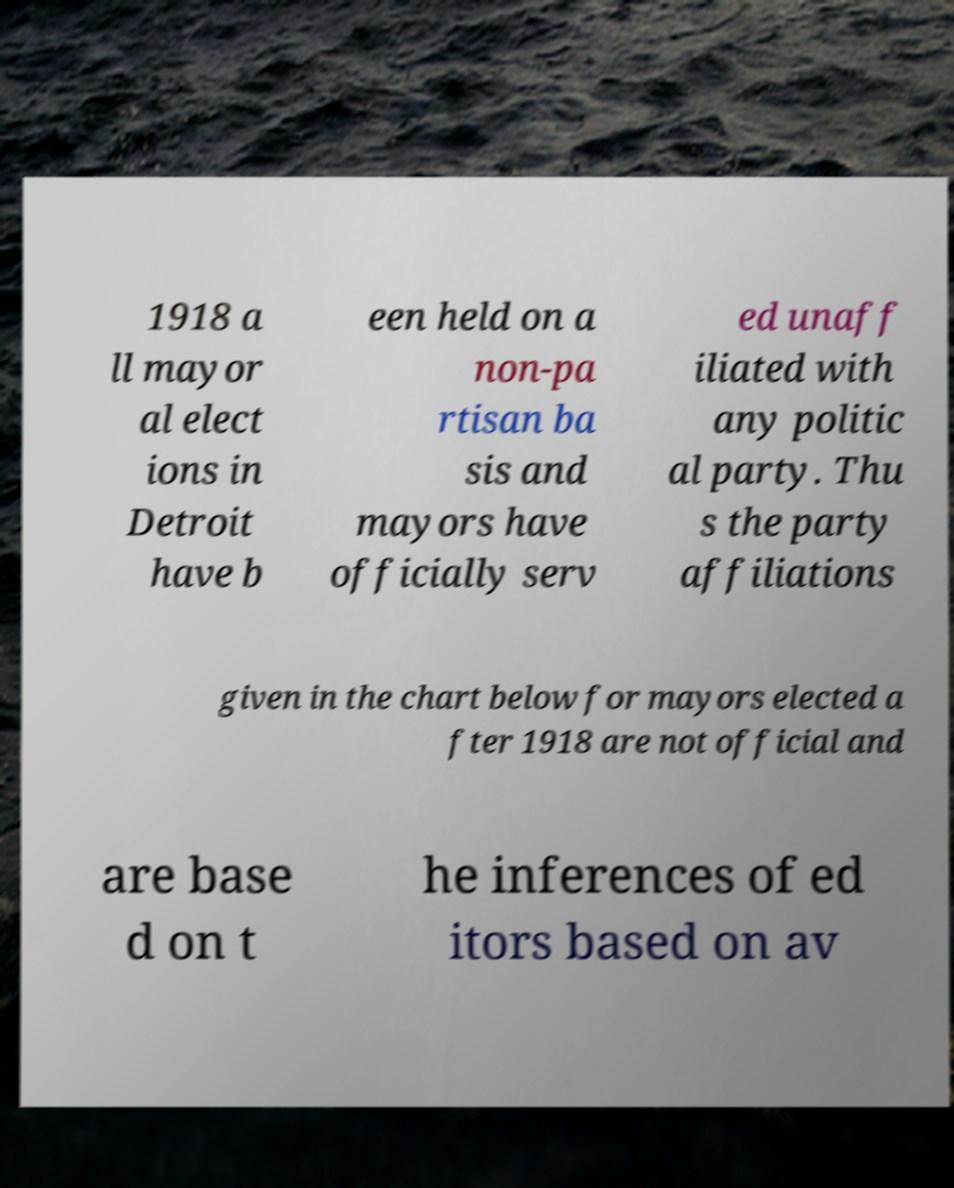Please identify and transcribe the text found in this image. 1918 a ll mayor al elect ions in Detroit have b een held on a non-pa rtisan ba sis and mayors have officially serv ed unaff iliated with any politic al party. Thu s the party affiliations given in the chart below for mayors elected a fter 1918 are not official and are base d on t he inferences of ed itors based on av 